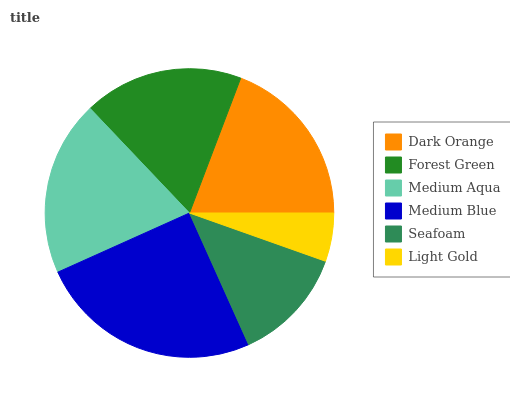Is Light Gold the minimum?
Answer yes or no. Yes. Is Medium Blue the maximum?
Answer yes or no. Yes. Is Forest Green the minimum?
Answer yes or no. No. Is Forest Green the maximum?
Answer yes or no. No. Is Dark Orange greater than Forest Green?
Answer yes or no. Yes. Is Forest Green less than Dark Orange?
Answer yes or no. Yes. Is Forest Green greater than Dark Orange?
Answer yes or no. No. Is Dark Orange less than Forest Green?
Answer yes or no. No. Is Dark Orange the high median?
Answer yes or no. Yes. Is Forest Green the low median?
Answer yes or no. Yes. Is Medium Aqua the high median?
Answer yes or no. No. Is Dark Orange the low median?
Answer yes or no. No. 